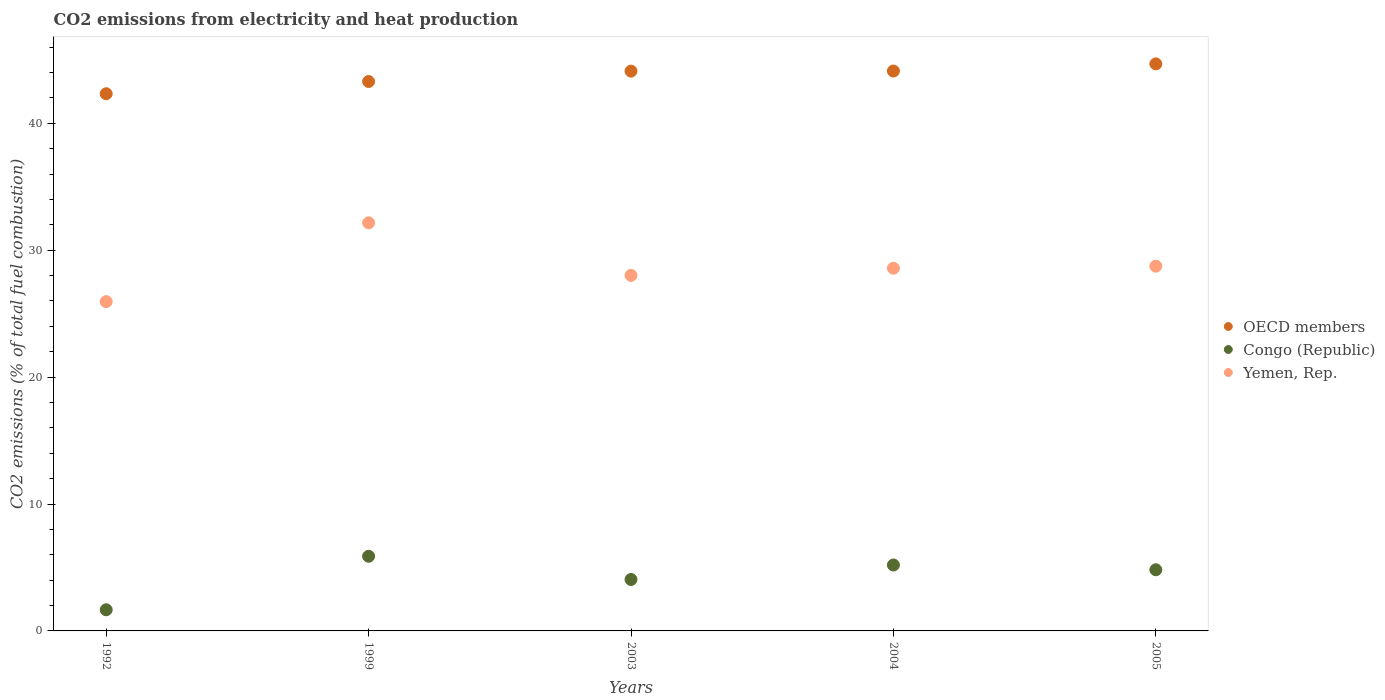What is the amount of CO2 emitted in Congo (Republic) in 2004?
Your response must be concise. 5.19. Across all years, what is the maximum amount of CO2 emitted in Yemen, Rep.?
Offer a terse response. 32.16. Across all years, what is the minimum amount of CO2 emitted in Congo (Republic)?
Make the answer very short. 1.67. What is the total amount of CO2 emitted in Congo (Republic) in the graph?
Your response must be concise. 21.62. What is the difference between the amount of CO2 emitted in OECD members in 1999 and that in 2003?
Keep it short and to the point. -0.82. What is the difference between the amount of CO2 emitted in Yemen, Rep. in 2004 and the amount of CO2 emitted in OECD members in 2005?
Make the answer very short. -16.1. What is the average amount of CO2 emitted in OECD members per year?
Offer a very short reply. 43.71. In the year 2005, what is the difference between the amount of CO2 emitted in Yemen, Rep. and amount of CO2 emitted in Congo (Republic)?
Your response must be concise. 23.92. In how many years, is the amount of CO2 emitted in Yemen, Rep. greater than 14 %?
Ensure brevity in your answer.  5. What is the ratio of the amount of CO2 emitted in Yemen, Rep. in 1992 to that in 2004?
Keep it short and to the point. 0.91. Is the amount of CO2 emitted in OECD members in 1992 less than that in 1999?
Make the answer very short. Yes. Is the difference between the amount of CO2 emitted in Yemen, Rep. in 2003 and 2005 greater than the difference between the amount of CO2 emitted in Congo (Republic) in 2003 and 2005?
Provide a short and direct response. Yes. What is the difference between the highest and the second highest amount of CO2 emitted in Yemen, Rep.?
Your answer should be very brief. 3.42. What is the difference between the highest and the lowest amount of CO2 emitted in Congo (Republic)?
Give a very brief answer. 4.22. In how many years, is the amount of CO2 emitted in Congo (Republic) greater than the average amount of CO2 emitted in Congo (Republic) taken over all years?
Offer a very short reply. 3. Is the sum of the amount of CO2 emitted in Congo (Republic) in 2003 and 2005 greater than the maximum amount of CO2 emitted in Yemen, Rep. across all years?
Offer a very short reply. No. Is it the case that in every year, the sum of the amount of CO2 emitted in Congo (Republic) and amount of CO2 emitted in OECD members  is greater than the amount of CO2 emitted in Yemen, Rep.?
Offer a very short reply. Yes. Is the amount of CO2 emitted in OECD members strictly greater than the amount of CO2 emitted in Congo (Republic) over the years?
Provide a short and direct response. Yes. Is the amount of CO2 emitted in Yemen, Rep. strictly less than the amount of CO2 emitted in OECD members over the years?
Make the answer very short. Yes. Are the values on the major ticks of Y-axis written in scientific E-notation?
Your response must be concise. No. Does the graph contain any zero values?
Your answer should be very brief. No. What is the title of the graph?
Keep it short and to the point. CO2 emissions from electricity and heat production. What is the label or title of the X-axis?
Your answer should be compact. Years. What is the label or title of the Y-axis?
Your answer should be compact. CO2 emissions (% of total fuel combustion). What is the CO2 emissions (% of total fuel combustion) of OECD members in 1992?
Keep it short and to the point. 42.33. What is the CO2 emissions (% of total fuel combustion) of Congo (Republic) in 1992?
Your answer should be compact. 1.67. What is the CO2 emissions (% of total fuel combustion) in Yemen, Rep. in 1992?
Make the answer very short. 25.95. What is the CO2 emissions (% of total fuel combustion) in OECD members in 1999?
Provide a short and direct response. 43.29. What is the CO2 emissions (% of total fuel combustion) in Congo (Republic) in 1999?
Provide a succinct answer. 5.88. What is the CO2 emissions (% of total fuel combustion) in Yemen, Rep. in 1999?
Offer a terse response. 32.16. What is the CO2 emissions (% of total fuel combustion) of OECD members in 2003?
Offer a terse response. 44.11. What is the CO2 emissions (% of total fuel combustion) in Congo (Republic) in 2003?
Give a very brief answer. 4.05. What is the CO2 emissions (% of total fuel combustion) of Yemen, Rep. in 2003?
Provide a succinct answer. 28.01. What is the CO2 emissions (% of total fuel combustion) of OECD members in 2004?
Provide a short and direct response. 44.12. What is the CO2 emissions (% of total fuel combustion) of Congo (Republic) in 2004?
Keep it short and to the point. 5.19. What is the CO2 emissions (% of total fuel combustion) of Yemen, Rep. in 2004?
Ensure brevity in your answer.  28.58. What is the CO2 emissions (% of total fuel combustion) in OECD members in 2005?
Your answer should be compact. 44.68. What is the CO2 emissions (% of total fuel combustion) of Congo (Republic) in 2005?
Your answer should be compact. 4.82. What is the CO2 emissions (% of total fuel combustion) in Yemen, Rep. in 2005?
Offer a very short reply. 28.74. Across all years, what is the maximum CO2 emissions (% of total fuel combustion) in OECD members?
Keep it short and to the point. 44.68. Across all years, what is the maximum CO2 emissions (% of total fuel combustion) in Congo (Republic)?
Your response must be concise. 5.88. Across all years, what is the maximum CO2 emissions (% of total fuel combustion) of Yemen, Rep.?
Give a very brief answer. 32.16. Across all years, what is the minimum CO2 emissions (% of total fuel combustion) of OECD members?
Provide a short and direct response. 42.33. Across all years, what is the minimum CO2 emissions (% of total fuel combustion) of Congo (Republic)?
Offer a very short reply. 1.67. Across all years, what is the minimum CO2 emissions (% of total fuel combustion) of Yemen, Rep.?
Provide a succinct answer. 25.95. What is the total CO2 emissions (% of total fuel combustion) of OECD members in the graph?
Your response must be concise. 218.53. What is the total CO2 emissions (% of total fuel combustion) of Congo (Republic) in the graph?
Give a very brief answer. 21.62. What is the total CO2 emissions (% of total fuel combustion) in Yemen, Rep. in the graph?
Provide a short and direct response. 143.44. What is the difference between the CO2 emissions (% of total fuel combustion) of OECD members in 1992 and that in 1999?
Offer a very short reply. -0.96. What is the difference between the CO2 emissions (% of total fuel combustion) of Congo (Republic) in 1992 and that in 1999?
Provide a succinct answer. -4.22. What is the difference between the CO2 emissions (% of total fuel combustion) in Yemen, Rep. in 1992 and that in 1999?
Provide a short and direct response. -6.21. What is the difference between the CO2 emissions (% of total fuel combustion) in OECD members in 1992 and that in 2003?
Offer a very short reply. -1.78. What is the difference between the CO2 emissions (% of total fuel combustion) of Congo (Republic) in 1992 and that in 2003?
Provide a short and direct response. -2.39. What is the difference between the CO2 emissions (% of total fuel combustion) of Yemen, Rep. in 1992 and that in 2003?
Keep it short and to the point. -2.07. What is the difference between the CO2 emissions (% of total fuel combustion) in OECD members in 1992 and that in 2004?
Keep it short and to the point. -1.79. What is the difference between the CO2 emissions (% of total fuel combustion) of Congo (Republic) in 1992 and that in 2004?
Give a very brief answer. -3.53. What is the difference between the CO2 emissions (% of total fuel combustion) in Yemen, Rep. in 1992 and that in 2004?
Make the answer very short. -2.63. What is the difference between the CO2 emissions (% of total fuel combustion) in OECD members in 1992 and that in 2005?
Keep it short and to the point. -2.35. What is the difference between the CO2 emissions (% of total fuel combustion) of Congo (Republic) in 1992 and that in 2005?
Ensure brevity in your answer.  -3.15. What is the difference between the CO2 emissions (% of total fuel combustion) of Yemen, Rep. in 1992 and that in 2005?
Offer a terse response. -2.79. What is the difference between the CO2 emissions (% of total fuel combustion) in OECD members in 1999 and that in 2003?
Keep it short and to the point. -0.82. What is the difference between the CO2 emissions (% of total fuel combustion) in Congo (Republic) in 1999 and that in 2003?
Provide a succinct answer. 1.83. What is the difference between the CO2 emissions (% of total fuel combustion) in Yemen, Rep. in 1999 and that in 2003?
Keep it short and to the point. 4.14. What is the difference between the CO2 emissions (% of total fuel combustion) of OECD members in 1999 and that in 2004?
Your response must be concise. -0.83. What is the difference between the CO2 emissions (% of total fuel combustion) of Congo (Republic) in 1999 and that in 2004?
Offer a terse response. 0.69. What is the difference between the CO2 emissions (% of total fuel combustion) in Yemen, Rep. in 1999 and that in 2004?
Offer a terse response. 3.58. What is the difference between the CO2 emissions (% of total fuel combustion) of OECD members in 1999 and that in 2005?
Your response must be concise. -1.39. What is the difference between the CO2 emissions (% of total fuel combustion) of Congo (Republic) in 1999 and that in 2005?
Your response must be concise. 1.06. What is the difference between the CO2 emissions (% of total fuel combustion) in Yemen, Rep. in 1999 and that in 2005?
Your answer should be very brief. 3.42. What is the difference between the CO2 emissions (% of total fuel combustion) in OECD members in 2003 and that in 2004?
Your answer should be compact. -0.01. What is the difference between the CO2 emissions (% of total fuel combustion) of Congo (Republic) in 2003 and that in 2004?
Give a very brief answer. -1.14. What is the difference between the CO2 emissions (% of total fuel combustion) in Yemen, Rep. in 2003 and that in 2004?
Your answer should be very brief. -0.57. What is the difference between the CO2 emissions (% of total fuel combustion) of OECD members in 2003 and that in 2005?
Your answer should be compact. -0.57. What is the difference between the CO2 emissions (% of total fuel combustion) in Congo (Republic) in 2003 and that in 2005?
Your answer should be very brief. -0.77. What is the difference between the CO2 emissions (% of total fuel combustion) in Yemen, Rep. in 2003 and that in 2005?
Give a very brief answer. -0.73. What is the difference between the CO2 emissions (% of total fuel combustion) of OECD members in 2004 and that in 2005?
Your answer should be compact. -0.56. What is the difference between the CO2 emissions (% of total fuel combustion) in Congo (Republic) in 2004 and that in 2005?
Your answer should be very brief. 0.38. What is the difference between the CO2 emissions (% of total fuel combustion) in Yemen, Rep. in 2004 and that in 2005?
Offer a very short reply. -0.16. What is the difference between the CO2 emissions (% of total fuel combustion) in OECD members in 1992 and the CO2 emissions (% of total fuel combustion) in Congo (Republic) in 1999?
Ensure brevity in your answer.  36.45. What is the difference between the CO2 emissions (% of total fuel combustion) of OECD members in 1992 and the CO2 emissions (% of total fuel combustion) of Yemen, Rep. in 1999?
Make the answer very short. 10.17. What is the difference between the CO2 emissions (% of total fuel combustion) in Congo (Republic) in 1992 and the CO2 emissions (% of total fuel combustion) in Yemen, Rep. in 1999?
Make the answer very short. -30.49. What is the difference between the CO2 emissions (% of total fuel combustion) in OECD members in 1992 and the CO2 emissions (% of total fuel combustion) in Congo (Republic) in 2003?
Ensure brevity in your answer.  38.27. What is the difference between the CO2 emissions (% of total fuel combustion) of OECD members in 1992 and the CO2 emissions (% of total fuel combustion) of Yemen, Rep. in 2003?
Your response must be concise. 14.31. What is the difference between the CO2 emissions (% of total fuel combustion) of Congo (Republic) in 1992 and the CO2 emissions (% of total fuel combustion) of Yemen, Rep. in 2003?
Keep it short and to the point. -26.35. What is the difference between the CO2 emissions (% of total fuel combustion) of OECD members in 1992 and the CO2 emissions (% of total fuel combustion) of Congo (Republic) in 2004?
Offer a very short reply. 37.13. What is the difference between the CO2 emissions (% of total fuel combustion) of OECD members in 1992 and the CO2 emissions (% of total fuel combustion) of Yemen, Rep. in 2004?
Give a very brief answer. 13.75. What is the difference between the CO2 emissions (% of total fuel combustion) in Congo (Republic) in 1992 and the CO2 emissions (% of total fuel combustion) in Yemen, Rep. in 2004?
Offer a very short reply. -26.91. What is the difference between the CO2 emissions (% of total fuel combustion) of OECD members in 1992 and the CO2 emissions (% of total fuel combustion) of Congo (Republic) in 2005?
Give a very brief answer. 37.51. What is the difference between the CO2 emissions (% of total fuel combustion) in OECD members in 1992 and the CO2 emissions (% of total fuel combustion) in Yemen, Rep. in 2005?
Ensure brevity in your answer.  13.59. What is the difference between the CO2 emissions (% of total fuel combustion) in Congo (Republic) in 1992 and the CO2 emissions (% of total fuel combustion) in Yemen, Rep. in 2005?
Offer a terse response. -27.07. What is the difference between the CO2 emissions (% of total fuel combustion) in OECD members in 1999 and the CO2 emissions (% of total fuel combustion) in Congo (Republic) in 2003?
Your response must be concise. 39.24. What is the difference between the CO2 emissions (% of total fuel combustion) in OECD members in 1999 and the CO2 emissions (% of total fuel combustion) in Yemen, Rep. in 2003?
Make the answer very short. 15.28. What is the difference between the CO2 emissions (% of total fuel combustion) of Congo (Republic) in 1999 and the CO2 emissions (% of total fuel combustion) of Yemen, Rep. in 2003?
Make the answer very short. -22.13. What is the difference between the CO2 emissions (% of total fuel combustion) in OECD members in 1999 and the CO2 emissions (% of total fuel combustion) in Congo (Republic) in 2004?
Make the answer very short. 38.1. What is the difference between the CO2 emissions (% of total fuel combustion) in OECD members in 1999 and the CO2 emissions (% of total fuel combustion) in Yemen, Rep. in 2004?
Your response must be concise. 14.71. What is the difference between the CO2 emissions (% of total fuel combustion) of Congo (Republic) in 1999 and the CO2 emissions (% of total fuel combustion) of Yemen, Rep. in 2004?
Keep it short and to the point. -22.7. What is the difference between the CO2 emissions (% of total fuel combustion) of OECD members in 1999 and the CO2 emissions (% of total fuel combustion) of Congo (Republic) in 2005?
Offer a very short reply. 38.47. What is the difference between the CO2 emissions (% of total fuel combustion) in OECD members in 1999 and the CO2 emissions (% of total fuel combustion) in Yemen, Rep. in 2005?
Provide a succinct answer. 14.55. What is the difference between the CO2 emissions (% of total fuel combustion) in Congo (Republic) in 1999 and the CO2 emissions (% of total fuel combustion) in Yemen, Rep. in 2005?
Provide a short and direct response. -22.86. What is the difference between the CO2 emissions (% of total fuel combustion) of OECD members in 2003 and the CO2 emissions (% of total fuel combustion) of Congo (Republic) in 2004?
Your answer should be very brief. 38.91. What is the difference between the CO2 emissions (% of total fuel combustion) in OECD members in 2003 and the CO2 emissions (% of total fuel combustion) in Yemen, Rep. in 2004?
Your response must be concise. 15.53. What is the difference between the CO2 emissions (% of total fuel combustion) of Congo (Republic) in 2003 and the CO2 emissions (% of total fuel combustion) of Yemen, Rep. in 2004?
Your answer should be very brief. -24.53. What is the difference between the CO2 emissions (% of total fuel combustion) of OECD members in 2003 and the CO2 emissions (% of total fuel combustion) of Congo (Republic) in 2005?
Your answer should be very brief. 39.29. What is the difference between the CO2 emissions (% of total fuel combustion) of OECD members in 2003 and the CO2 emissions (% of total fuel combustion) of Yemen, Rep. in 2005?
Provide a short and direct response. 15.37. What is the difference between the CO2 emissions (% of total fuel combustion) of Congo (Republic) in 2003 and the CO2 emissions (% of total fuel combustion) of Yemen, Rep. in 2005?
Give a very brief answer. -24.69. What is the difference between the CO2 emissions (% of total fuel combustion) in OECD members in 2004 and the CO2 emissions (% of total fuel combustion) in Congo (Republic) in 2005?
Make the answer very short. 39.3. What is the difference between the CO2 emissions (% of total fuel combustion) in OECD members in 2004 and the CO2 emissions (% of total fuel combustion) in Yemen, Rep. in 2005?
Ensure brevity in your answer.  15.38. What is the difference between the CO2 emissions (% of total fuel combustion) of Congo (Republic) in 2004 and the CO2 emissions (% of total fuel combustion) of Yemen, Rep. in 2005?
Provide a succinct answer. -23.55. What is the average CO2 emissions (% of total fuel combustion) in OECD members per year?
Offer a terse response. 43.71. What is the average CO2 emissions (% of total fuel combustion) in Congo (Republic) per year?
Provide a short and direct response. 4.32. What is the average CO2 emissions (% of total fuel combustion) of Yemen, Rep. per year?
Your response must be concise. 28.69. In the year 1992, what is the difference between the CO2 emissions (% of total fuel combustion) in OECD members and CO2 emissions (% of total fuel combustion) in Congo (Republic)?
Your answer should be very brief. 40.66. In the year 1992, what is the difference between the CO2 emissions (% of total fuel combustion) in OECD members and CO2 emissions (% of total fuel combustion) in Yemen, Rep.?
Your response must be concise. 16.38. In the year 1992, what is the difference between the CO2 emissions (% of total fuel combustion) in Congo (Republic) and CO2 emissions (% of total fuel combustion) in Yemen, Rep.?
Provide a succinct answer. -24.28. In the year 1999, what is the difference between the CO2 emissions (% of total fuel combustion) in OECD members and CO2 emissions (% of total fuel combustion) in Congo (Republic)?
Keep it short and to the point. 37.41. In the year 1999, what is the difference between the CO2 emissions (% of total fuel combustion) in OECD members and CO2 emissions (% of total fuel combustion) in Yemen, Rep.?
Your response must be concise. 11.13. In the year 1999, what is the difference between the CO2 emissions (% of total fuel combustion) of Congo (Republic) and CO2 emissions (% of total fuel combustion) of Yemen, Rep.?
Your answer should be very brief. -26.27. In the year 2003, what is the difference between the CO2 emissions (% of total fuel combustion) of OECD members and CO2 emissions (% of total fuel combustion) of Congo (Republic)?
Offer a terse response. 40.05. In the year 2003, what is the difference between the CO2 emissions (% of total fuel combustion) in OECD members and CO2 emissions (% of total fuel combustion) in Yemen, Rep.?
Your answer should be very brief. 16.09. In the year 2003, what is the difference between the CO2 emissions (% of total fuel combustion) of Congo (Republic) and CO2 emissions (% of total fuel combustion) of Yemen, Rep.?
Give a very brief answer. -23.96. In the year 2004, what is the difference between the CO2 emissions (% of total fuel combustion) in OECD members and CO2 emissions (% of total fuel combustion) in Congo (Republic)?
Ensure brevity in your answer.  38.92. In the year 2004, what is the difference between the CO2 emissions (% of total fuel combustion) in OECD members and CO2 emissions (% of total fuel combustion) in Yemen, Rep.?
Provide a short and direct response. 15.54. In the year 2004, what is the difference between the CO2 emissions (% of total fuel combustion) in Congo (Republic) and CO2 emissions (% of total fuel combustion) in Yemen, Rep.?
Offer a terse response. -23.38. In the year 2005, what is the difference between the CO2 emissions (% of total fuel combustion) in OECD members and CO2 emissions (% of total fuel combustion) in Congo (Republic)?
Keep it short and to the point. 39.86. In the year 2005, what is the difference between the CO2 emissions (% of total fuel combustion) in OECD members and CO2 emissions (% of total fuel combustion) in Yemen, Rep.?
Your answer should be very brief. 15.94. In the year 2005, what is the difference between the CO2 emissions (% of total fuel combustion) in Congo (Republic) and CO2 emissions (% of total fuel combustion) in Yemen, Rep.?
Ensure brevity in your answer.  -23.92. What is the ratio of the CO2 emissions (% of total fuel combustion) in OECD members in 1992 to that in 1999?
Give a very brief answer. 0.98. What is the ratio of the CO2 emissions (% of total fuel combustion) of Congo (Republic) in 1992 to that in 1999?
Keep it short and to the point. 0.28. What is the ratio of the CO2 emissions (% of total fuel combustion) of Yemen, Rep. in 1992 to that in 1999?
Keep it short and to the point. 0.81. What is the ratio of the CO2 emissions (% of total fuel combustion) of OECD members in 1992 to that in 2003?
Keep it short and to the point. 0.96. What is the ratio of the CO2 emissions (% of total fuel combustion) of Congo (Republic) in 1992 to that in 2003?
Offer a terse response. 0.41. What is the ratio of the CO2 emissions (% of total fuel combustion) of Yemen, Rep. in 1992 to that in 2003?
Your response must be concise. 0.93. What is the ratio of the CO2 emissions (% of total fuel combustion) in OECD members in 1992 to that in 2004?
Offer a very short reply. 0.96. What is the ratio of the CO2 emissions (% of total fuel combustion) in Congo (Republic) in 1992 to that in 2004?
Provide a succinct answer. 0.32. What is the ratio of the CO2 emissions (% of total fuel combustion) of Yemen, Rep. in 1992 to that in 2004?
Ensure brevity in your answer.  0.91. What is the ratio of the CO2 emissions (% of total fuel combustion) of OECD members in 1992 to that in 2005?
Keep it short and to the point. 0.95. What is the ratio of the CO2 emissions (% of total fuel combustion) of Congo (Republic) in 1992 to that in 2005?
Give a very brief answer. 0.35. What is the ratio of the CO2 emissions (% of total fuel combustion) of Yemen, Rep. in 1992 to that in 2005?
Offer a terse response. 0.9. What is the ratio of the CO2 emissions (% of total fuel combustion) in OECD members in 1999 to that in 2003?
Provide a succinct answer. 0.98. What is the ratio of the CO2 emissions (% of total fuel combustion) in Congo (Republic) in 1999 to that in 2003?
Your answer should be compact. 1.45. What is the ratio of the CO2 emissions (% of total fuel combustion) of Yemen, Rep. in 1999 to that in 2003?
Your answer should be very brief. 1.15. What is the ratio of the CO2 emissions (% of total fuel combustion) of OECD members in 1999 to that in 2004?
Offer a very short reply. 0.98. What is the ratio of the CO2 emissions (% of total fuel combustion) of Congo (Republic) in 1999 to that in 2004?
Make the answer very short. 1.13. What is the ratio of the CO2 emissions (% of total fuel combustion) in Yemen, Rep. in 1999 to that in 2004?
Offer a very short reply. 1.13. What is the ratio of the CO2 emissions (% of total fuel combustion) in OECD members in 1999 to that in 2005?
Offer a terse response. 0.97. What is the ratio of the CO2 emissions (% of total fuel combustion) of Congo (Republic) in 1999 to that in 2005?
Provide a short and direct response. 1.22. What is the ratio of the CO2 emissions (% of total fuel combustion) in Yemen, Rep. in 1999 to that in 2005?
Keep it short and to the point. 1.12. What is the ratio of the CO2 emissions (% of total fuel combustion) in Congo (Republic) in 2003 to that in 2004?
Give a very brief answer. 0.78. What is the ratio of the CO2 emissions (% of total fuel combustion) of Yemen, Rep. in 2003 to that in 2004?
Your answer should be very brief. 0.98. What is the ratio of the CO2 emissions (% of total fuel combustion) of OECD members in 2003 to that in 2005?
Keep it short and to the point. 0.99. What is the ratio of the CO2 emissions (% of total fuel combustion) in Congo (Republic) in 2003 to that in 2005?
Offer a terse response. 0.84. What is the ratio of the CO2 emissions (% of total fuel combustion) in Yemen, Rep. in 2003 to that in 2005?
Provide a succinct answer. 0.97. What is the ratio of the CO2 emissions (% of total fuel combustion) in OECD members in 2004 to that in 2005?
Offer a very short reply. 0.99. What is the ratio of the CO2 emissions (% of total fuel combustion) in Congo (Republic) in 2004 to that in 2005?
Your response must be concise. 1.08. What is the ratio of the CO2 emissions (% of total fuel combustion) in Yemen, Rep. in 2004 to that in 2005?
Give a very brief answer. 0.99. What is the difference between the highest and the second highest CO2 emissions (% of total fuel combustion) in OECD members?
Ensure brevity in your answer.  0.56. What is the difference between the highest and the second highest CO2 emissions (% of total fuel combustion) of Congo (Republic)?
Give a very brief answer. 0.69. What is the difference between the highest and the second highest CO2 emissions (% of total fuel combustion) in Yemen, Rep.?
Make the answer very short. 3.42. What is the difference between the highest and the lowest CO2 emissions (% of total fuel combustion) in OECD members?
Keep it short and to the point. 2.35. What is the difference between the highest and the lowest CO2 emissions (% of total fuel combustion) in Congo (Republic)?
Your response must be concise. 4.22. What is the difference between the highest and the lowest CO2 emissions (% of total fuel combustion) of Yemen, Rep.?
Make the answer very short. 6.21. 